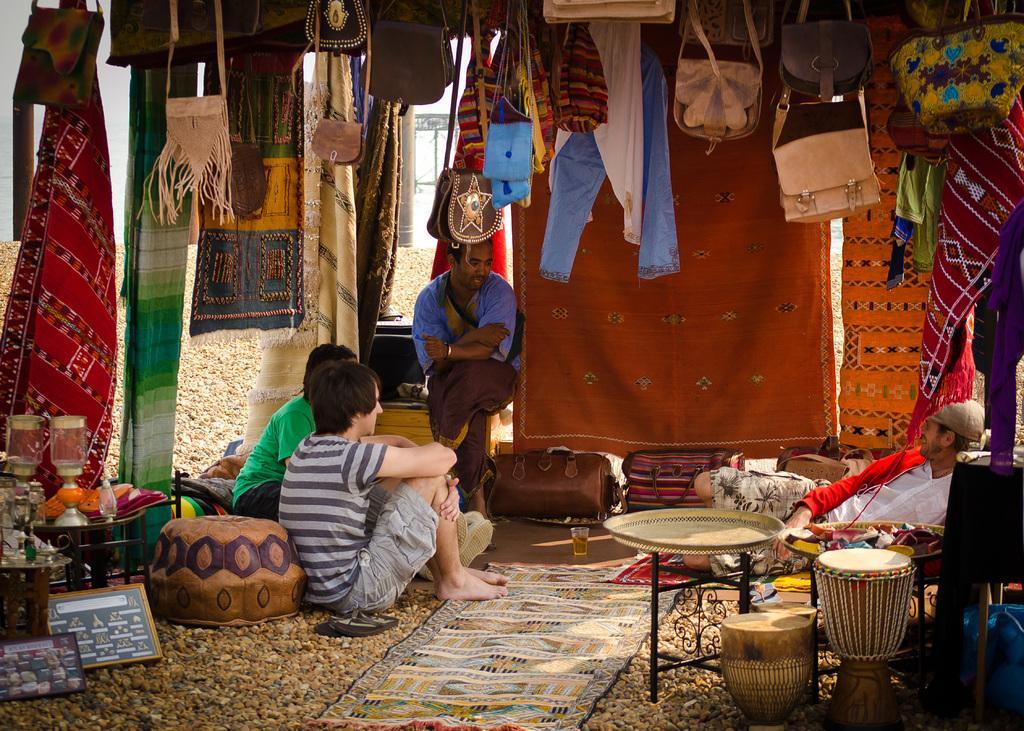How would you summarize this image in a sentence or two? This picture describes about group of people they are all seated, in this image we can see baggage, wallet, clothes and some objects. 